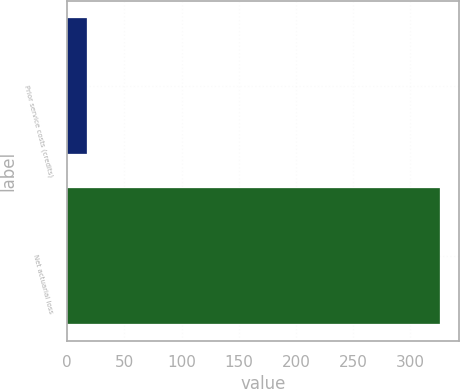Convert chart to OTSL. <chart><loc_0><loc_0><loc_500><loc_500><bar_chart><fcel>Prior service costs (credits)<fcel>Net actuarial loss<nl><fcel>17<fcel>326<nl></chart> 